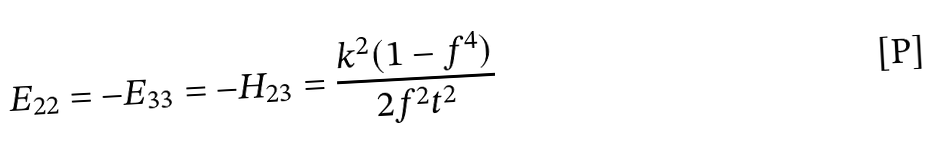Convert formula to latex. <formula><loc_0><loc_0><loc_500><loc_500>E _ { 2 2 } = - E _ { 3 3 } = - H _ { 2 3 } = \frac { k ^ { 2 } ( 1 - f ^ { 4 } ) } { 2 f ^ { 2 } t ^ { 2 } }</formula> 